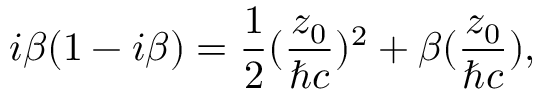<formula> <loc_0><loc_0><loc_500><loc_500>i { \beta } ( 1 - i { \beta } ) = \frac { 1 } { 2 } ( \frac { z _ { 0 } } { { } c } ) ^ { 2 } + { \beta } ( \frac { z _ { 0 } } { { } c } ) ,</formula> 